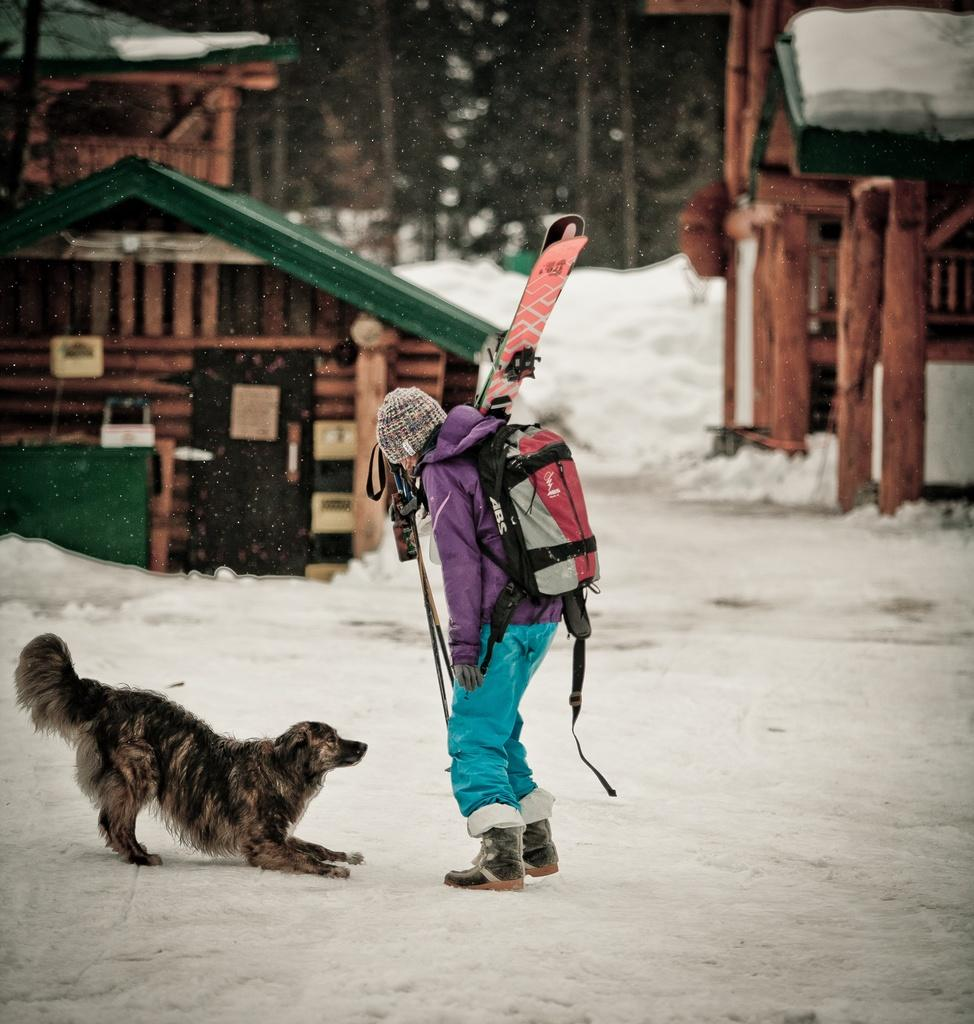Who or what is present in the image? There is a person and a dog in the image. What is the person wearing? The person is wearing a bag. What is the weather like in the image? There is snow visible in the image, indicating a cold or wintry environment. What type of structures can be seen in the image? There are houses in the image. What type of vegetation is present in the image? There are trees in the image. Can you hear the kettle boiling in the image? There is no kettle present in the image, so it is not possible to hear it boiling. 